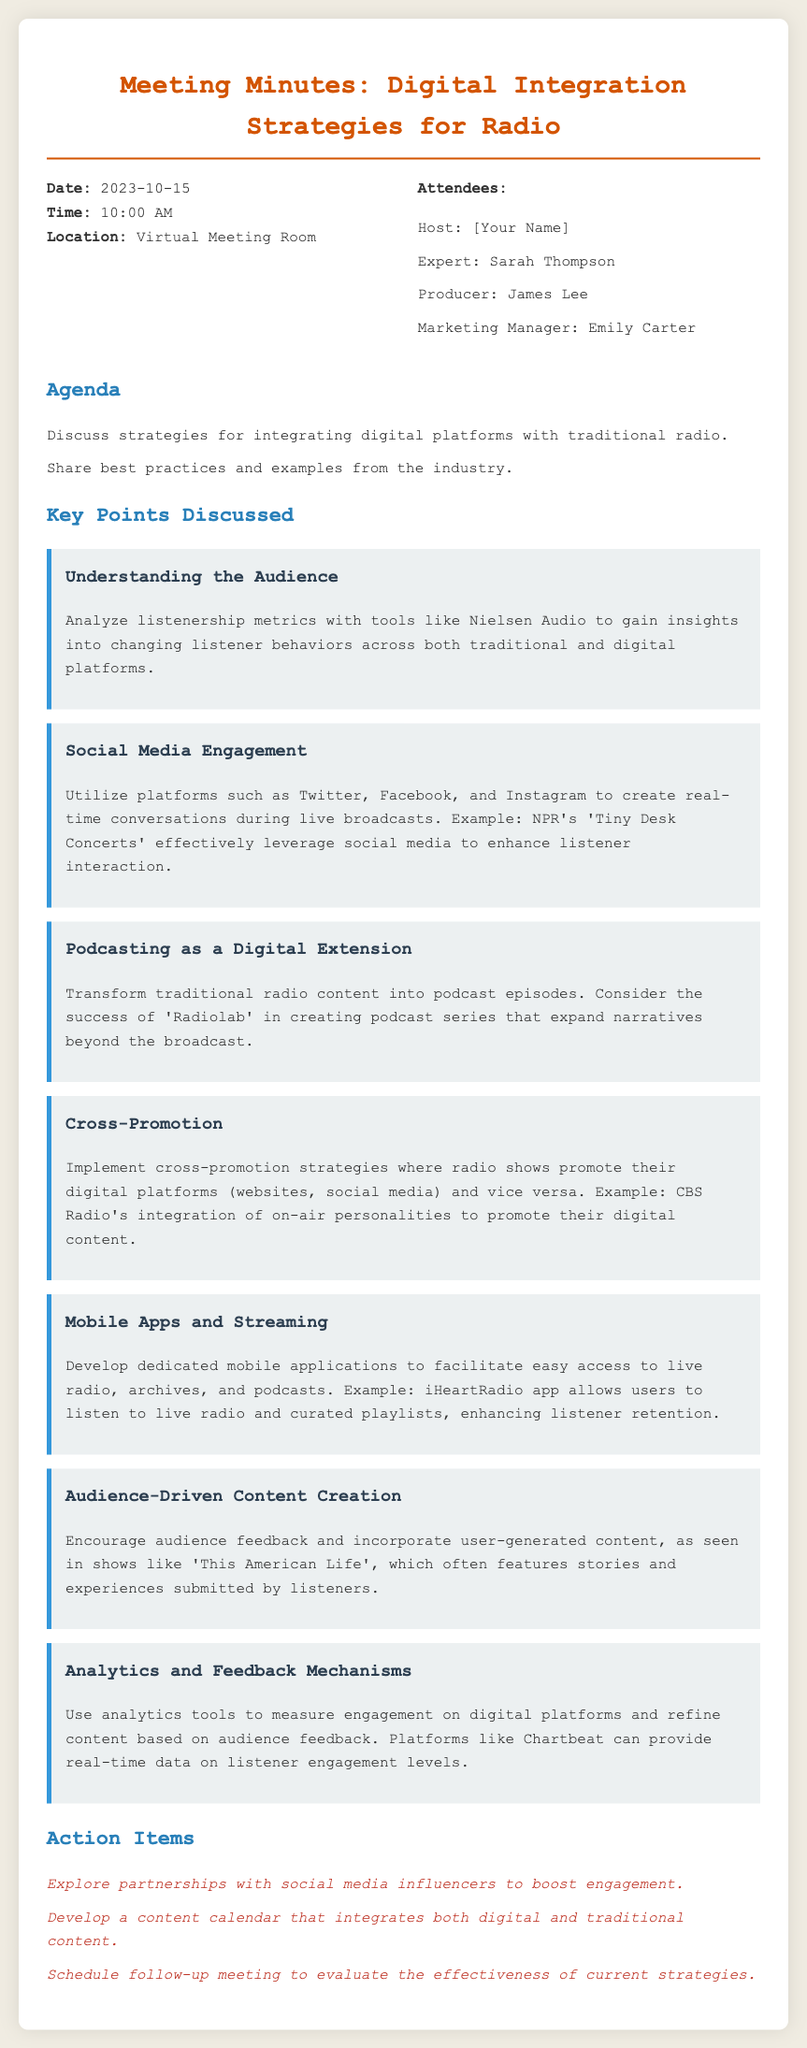What was the date of the meeting? The meeting date is explicitly stated in the document under the "Meeting Info" section.
Answer: 2023-10-15 Who hosted the meeting? The host of the meeting is listed in the "Meeting Info" section along with other attendees.
Answer: [Your Name] What was the main focus of the agenda? The agenda outlines the topics for discussion, which include integrating digital platforms with traditional radio.
Answer: Integrating digital platforms with traditional radio Which social media platform was referenced as an example for engagement during live broadcasts? The document mentions specific platforms used for real-time conversations among listeners during broadcasts.
Answer: Twitter, Facebook, and Instagram What is a strategy for creating audience-driven content? The document lists an approach towards content creation that encourages audience involvement.
Answer: Incorporate user-generated content What is one example of a successful podcast mentioned? The document provides an instance of a notable podcast that expanded narratives beyond traditional broadcasts.
Answer: Radiolab How many action items were identified in the meeting? The action items are clearly compiled in a list and countable.
Answer: Three What tool was suggested for measuring engagement on digital platforms? The document specifies analytics tools used to assess listener engagement.
Answer: Chartbeat 